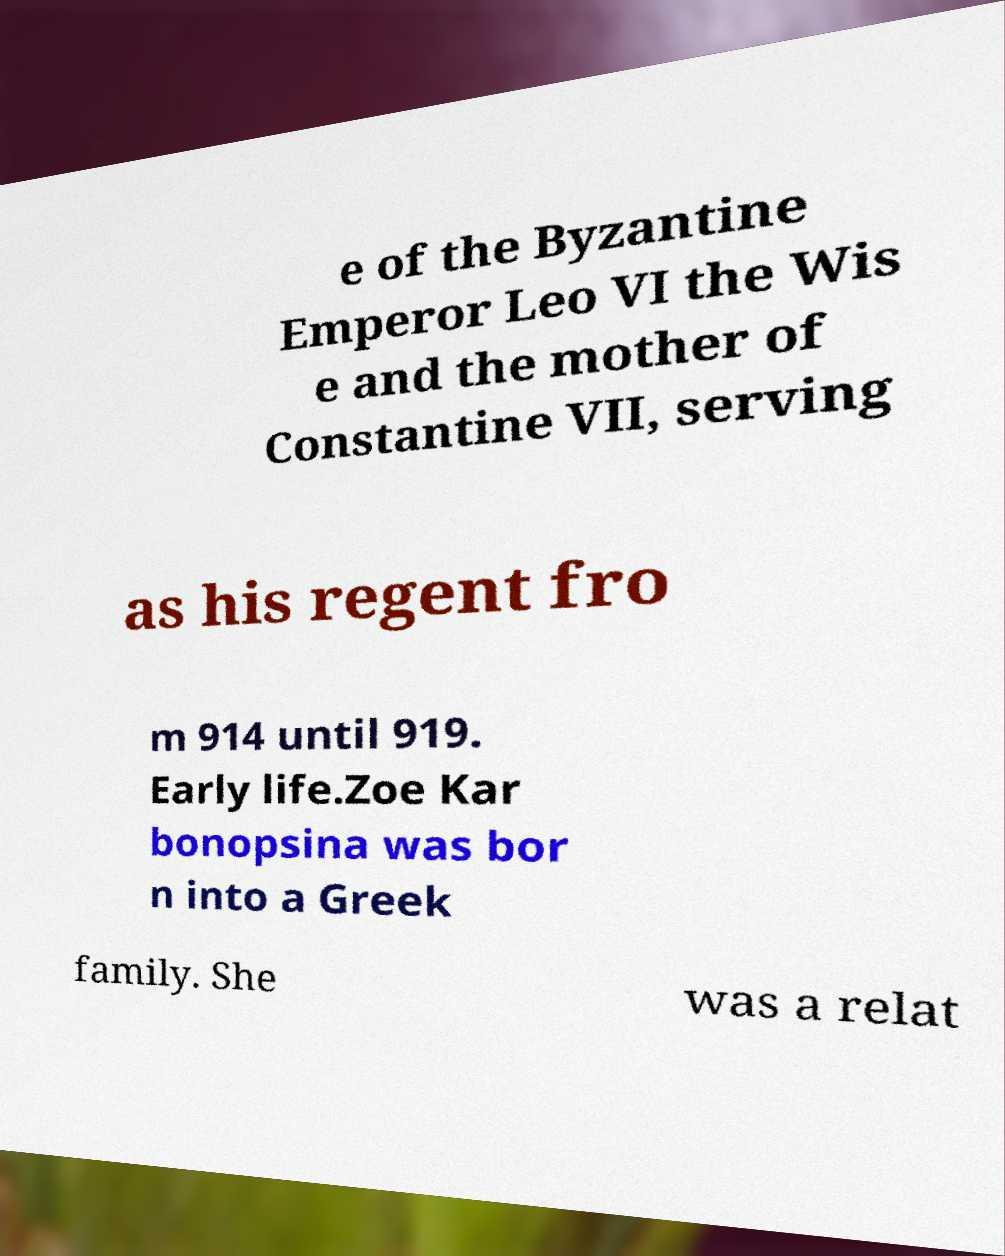There's text embedded in this image that I need extracted. Can you transcribe it verbatim? e of the Byzantine Emperor Leo VI the Wis e and the mother of Constantine VII, serving as his regent fro m 914 until 919. Early life.Zoe Kar bonopsina was bor n into a Greek family. She was a relat 